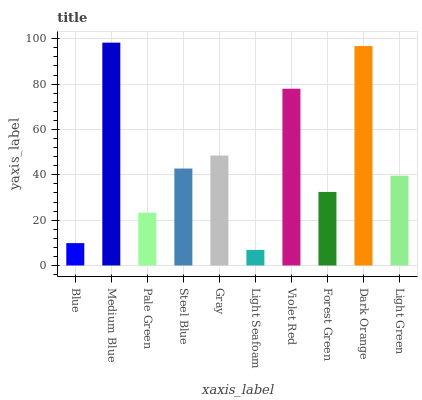Is Light Seafoam the minimum?
Answer yes or no. Yes. Is Medium Blue the maximum?
Answer yes or no. Yes. Is Pale Green the minimum?
Answer yes or no. No. Is Pale Green the maximum?
Answer yes or no. No. Is Medium Blue greater than Pale Green?
Answer yes or no. Yes. Is Pale Green less than Medium Blue?
Answer yes or no. Yes. Is Pale Green greater than Medium Blue?
Answer yes or no. No. Is Medium Blue less than Pale Green?
Answer yes or no. No. Is Steel Blue the high median?
Answer yes or no. Yes. Is Light Green the low median?
Answer yes or no. Yes. Is Light Seafoam the high median?
Answer yes or no. No. Is Medium Blue the low median?
Answer yes or no. No. 